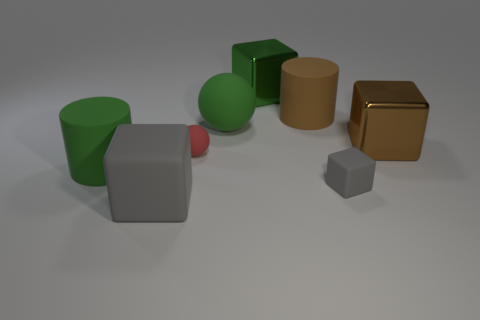Is there another brown cylinder that has the same material as the large brown cylinder?
Your response must be concise. No. There is a metal object to the left of the shiny object that is on the right side of the rubber cylinder that is on the right side of the green rubber cylinder; what shape is it?
Give a very brief answer. Cube. Do the large cube that is behind the large brown metallic cube and the matte object in front of the small block have the same color?
Your response must be concise. No. Is there any other thing that is the same size as the green cube?
Offer a terse response. Yes. There is a brown metallic block; are there any big brown cylinders in front of it?
Offer a terse response. No. How many large green rubber things are the same shape as the large gray rubber object?
Your answer should be very brief. 0. There is a cylinder on the left side of the green rubber object behind the tiny rubber object on the left side of the big green metal thing; what color is it?
Ensure brevity in your answer.  Green. Does the big cube that is behind the large brown matte cylinder have the same material as the cylinder right of the red rubber sphere?
Give a very brief answer. No. What number of objects are large brown objects in front of the brown rubber cylinder or big green rubber cylinders?
Give a very brief answer. 2. How many objects are big gray metal spheres or green objects that are left of the large matte ball?
Provide a succinct answer. 1. 